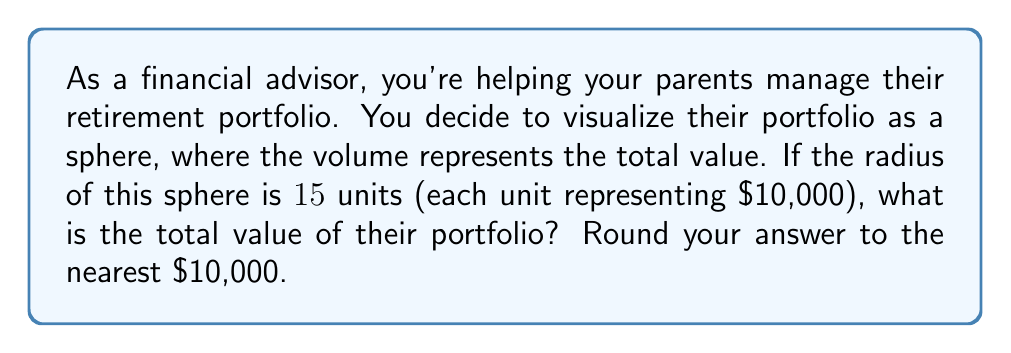Can you solve this math problem? To solve this problem, we need to follow these steps:

1) The formula for the volume of a sphere is:

   $$V = \frac{4}{3}\pi r^3$$

   where $V$ is the volume and $r$ is the radius.

2) We're given that the radius is 15 units. Let's substitute this into our formula:

   $$V = \frac{4}{3}\pi (15)^3$$

3) Let's calculate this step by step:
   
   $$V = \frac{4}{3}\pi (3375)$$
   $$V = 4\pi (1125)$$
   $$V = 4500\pi$$

4) Using 3.14159 as an approximation for $\pi$:

   $$V \approx 4500 (3.14159)$$
   $$V \approx 14137.155$$

5) Remember, each unit represents $10,000. So we need to multiply our result by 10,000:

   $$14137.155 * 10,000 = 141,371,550$$

6) Rounding to the nearest 10,000 as requested:

   $$141,370,000$$
Answer: $141,370,000 